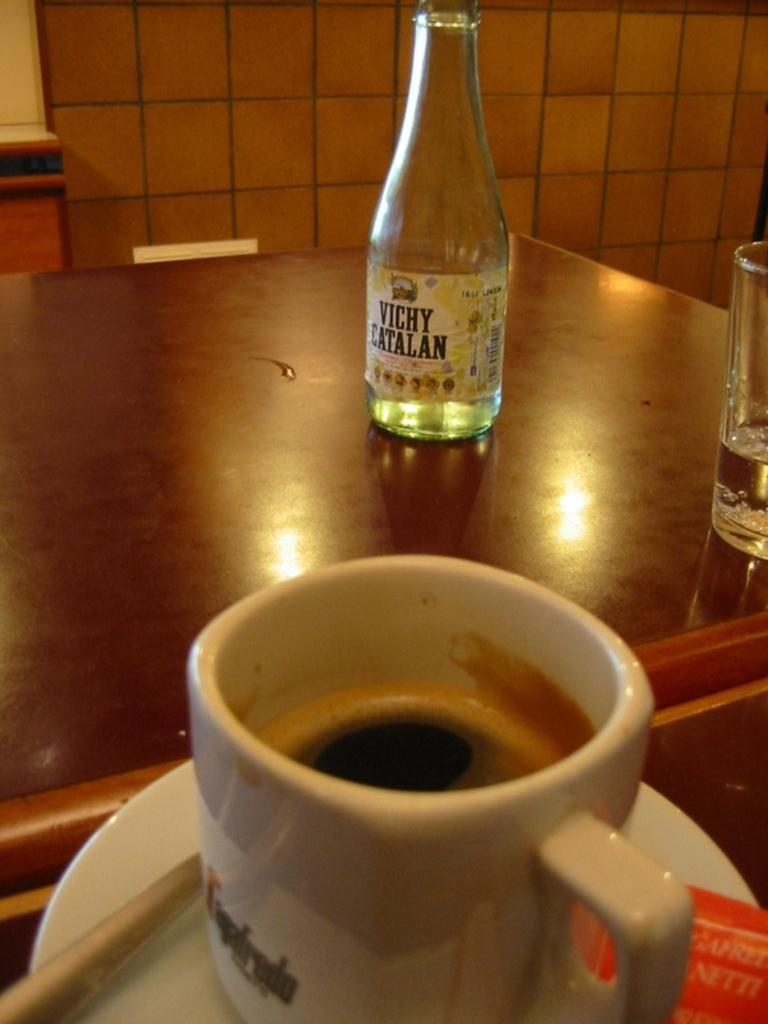<image>
Provide a brief description of the given image. Bottle of vichy catalan sits on a table on a table with a cup of coffee. 